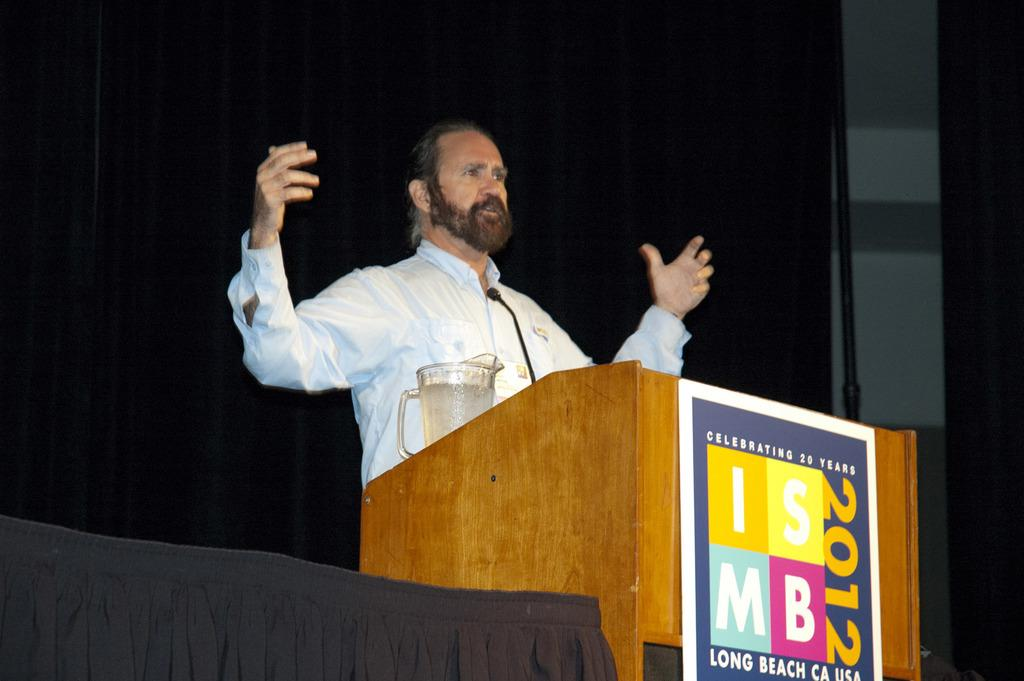Provide a one-sentence caption for the provided image. ISMB 2012 celebrated 20 years in Long Beach, California. 